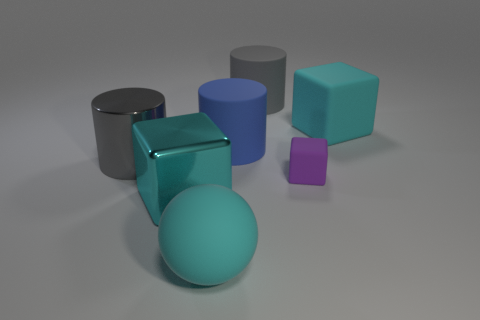Add 3 rubber cubes. How many objects exist? 10 Subtract all balls. How many objects are left? 6 Add 5 cyan metallic blocks. How many cyan metallic blocks are left? 6 Add 7 small blue cylinders. How many small blue cylinders exist? 7 Subtract 1 blue cylinders. How many objects are left? 6 Subtract all matte cylinders. Subtract all purple rubber cubes. How many objects are left? 4 